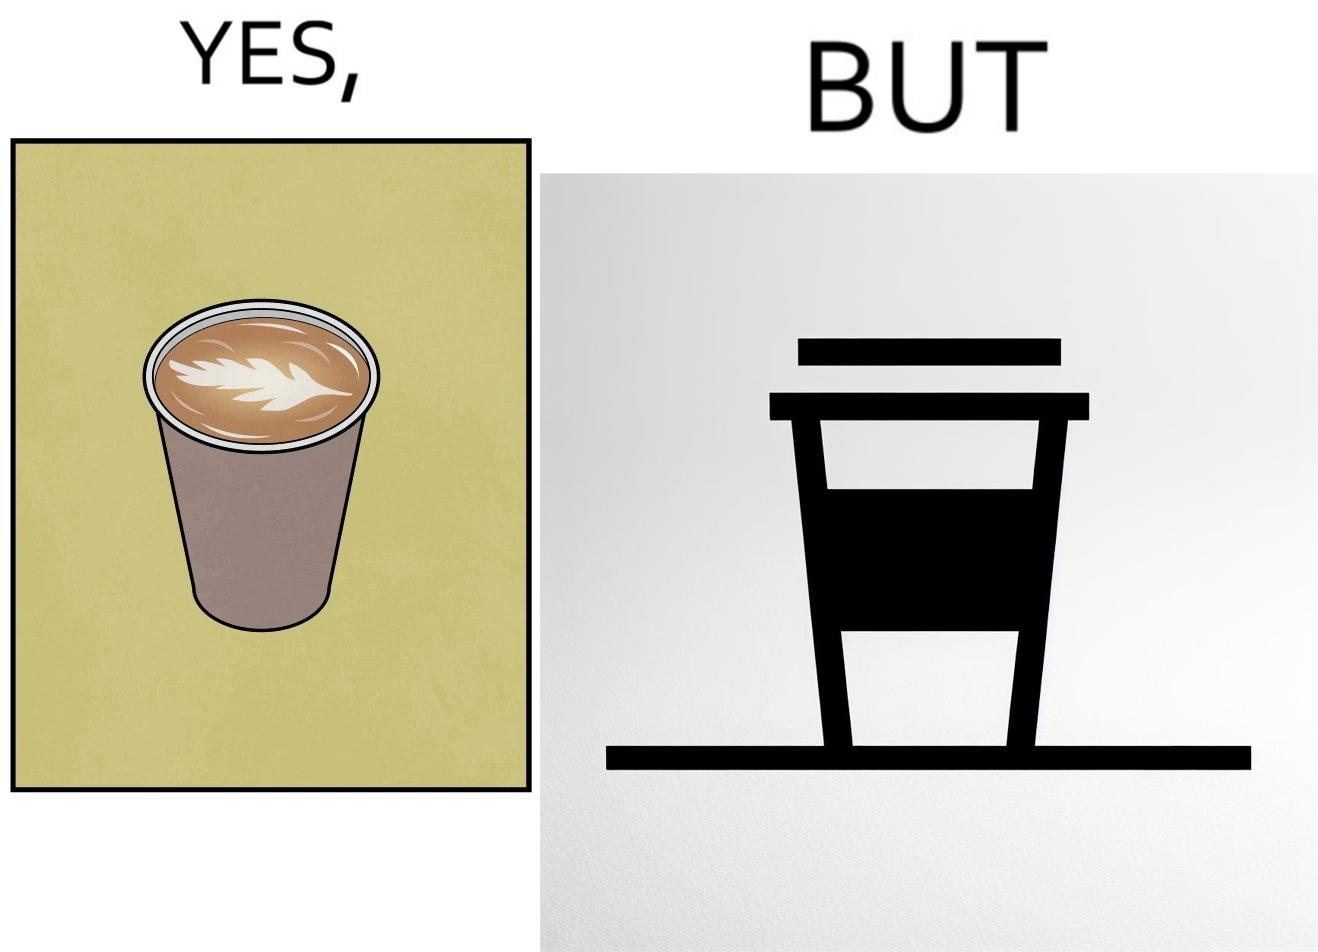What do you see in each half of this image? In the left part of the image: It is a cup of coffee with latte art In the right part of the image: It is a cup of coffee with its lid on top 